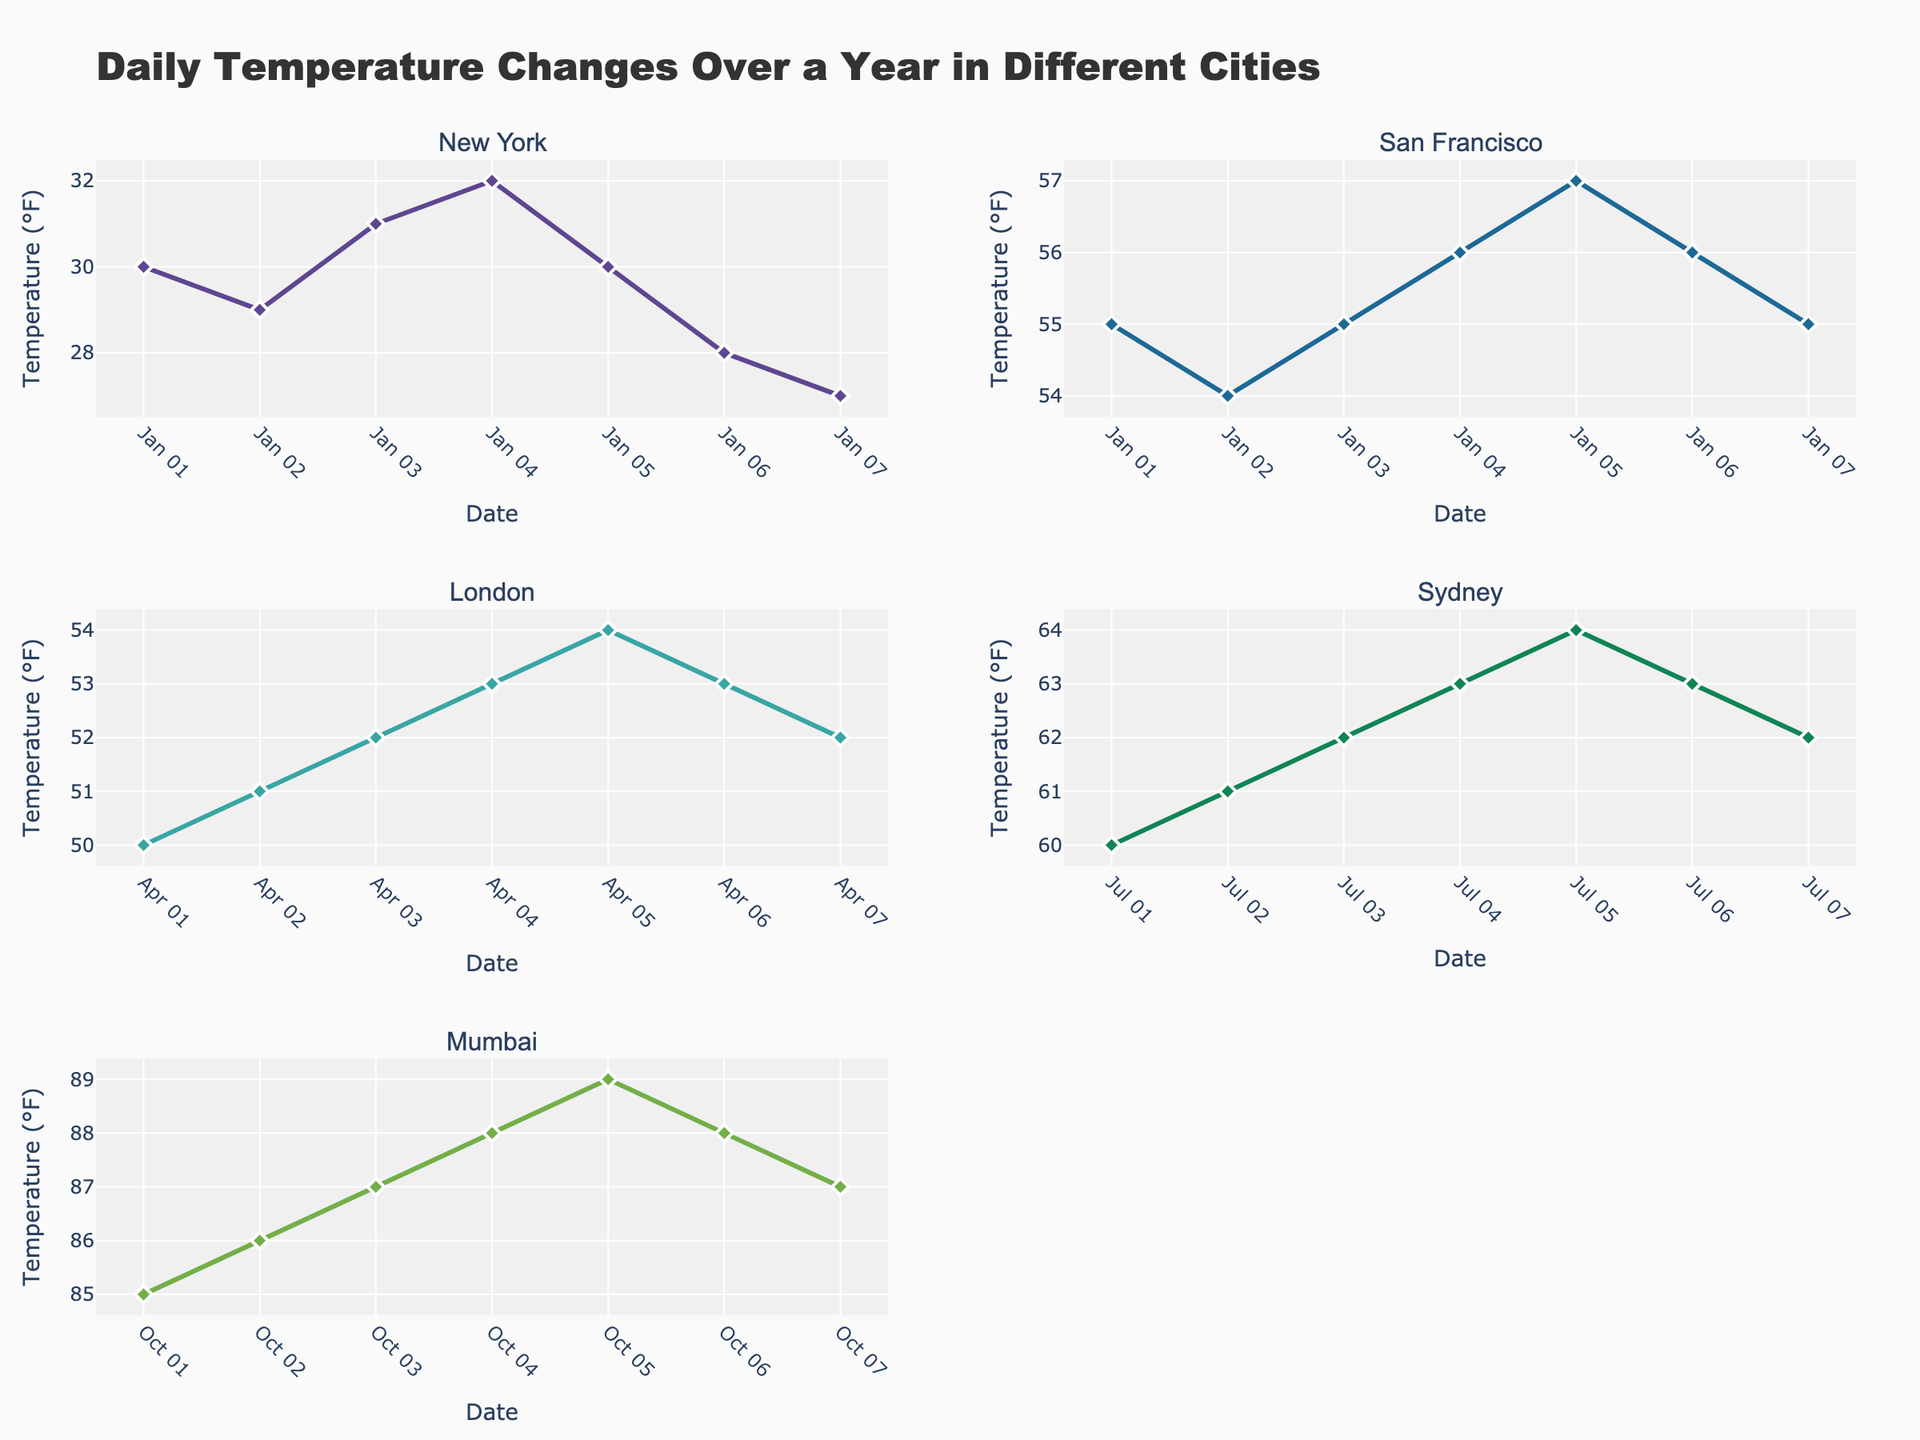what is the title of the figure? The title is located at the top of the plot and typically provides a summary of the figure's content. In this case, it reads "Daily Temperature Changes Over a Year in Different Cities."
Answer: Daily Temperature Changes Over a Year in Different Cities how many unique cities are represented in the figure? Each subplot in the figure is dedicated to a unique city. There are six subplots, meaning there are six unique cities depicted.
Answer: 6 which city shows the most stable temperature over the days plotted? Stability can be evaluated by observing the fluctuation in the temperature line of each city. San Francisco's line shows the least variation compared to others.
Answer: San Francisco what is the temperature range for New York in the plot? The temperature range is found by identifying the highest and lowest temperatures for New York. From the data, the highest temperature is 32°F, and the lowest is 27°F. Therefore, the range is 32 - 27 = 5°F.
Answer: 5°F what happens to the temperatures in Mumbai over the days plotted? By examining the line for Mumbai, we can see it initially increases, peaks at 89°F, and then decreases slightly.
Answer: Increases then decreases which city has the highest temperature recorded in the plot? Reviewing the highest data points in all subplots, Mumbai shows the highest temperature at 89°F on October 5th.
Answer: Mumbai compare the temperature on January 1st between New York and San Francisco On January 1st, New York's temperature is 30°F and San Francisco's is 55°F. San Francisco is warmer by 25°F.
Answer: San Francisco by 25°F which month shows data for London? By observing the x-axis labels under London's subplot, data is shown for dates in April.
Answer: April does any city show a temperature decrease every day in its timeframe? By looking at the downward trends, New York shows a consistent temperature decrease from January 1st to January 7th.
Answer: New York what is the trend of Sydney's temperature over the days plotted? Sydney's temperatures show an increasing trend up to July 5th, reaching 64°F, followed by a slight decline.
Answer: Increases then decreases 